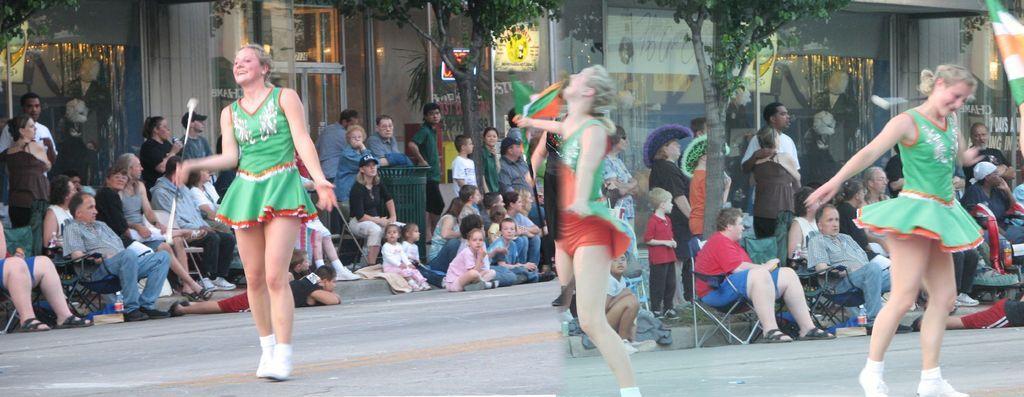Could you give a brief overview of what you see in this image? In the image we can see a collage photo. In it we can see a woman dancing, she is wearing clothes, socks and shoes. We can see there are even other people sitting and some of them are standing. Here we can see the building, trees, garbage bin and the road. 